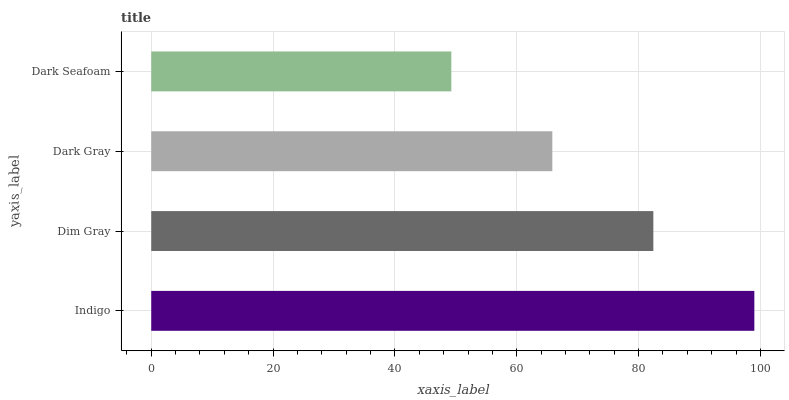Is Dark Seafoam the minimum?
Answer yes or no. Yes. Is Indigo the maximum?
Answer yes or no. Yes. Is Dim Gray the minimum?
Answer yes or no. No. Is Dim Gray the maximum?
Answer yes or no. No. Is Indigo greater than Dim Gray?
Answer yes or no. Yes. Is Dim Gray less than Indigo?
Answer yes or no. Yes. Is Dim Gray greater than Indigo?
Answer yes or no. No. Is Indigo less than Dim Gray?
Answer yes or no. No. Is Dim Gray the high median?
Answer yes or no. Yes. Is Dark Gray the low median?
Answer yes or no. Yes. Is Indigo the high median?
Answer yes or no. No. Is Dim Gray the low median?
Answer yes or no. No. 